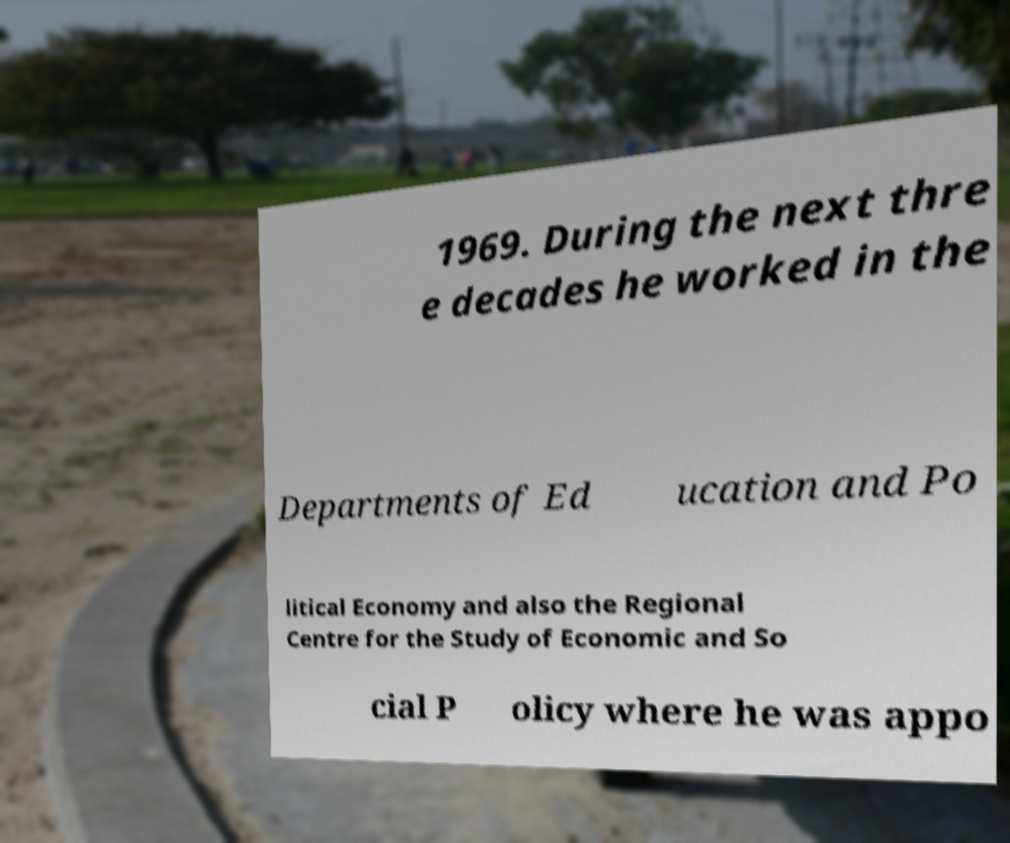For documentation purposes, I need the text within this image transcribed. Could you provide that? 1969. During the next thre e decades he worked in the Departments of Ed ucation and Po litical Economy and also the Regional Centre for the Study of Economic and So cial P olicy where he was appo 